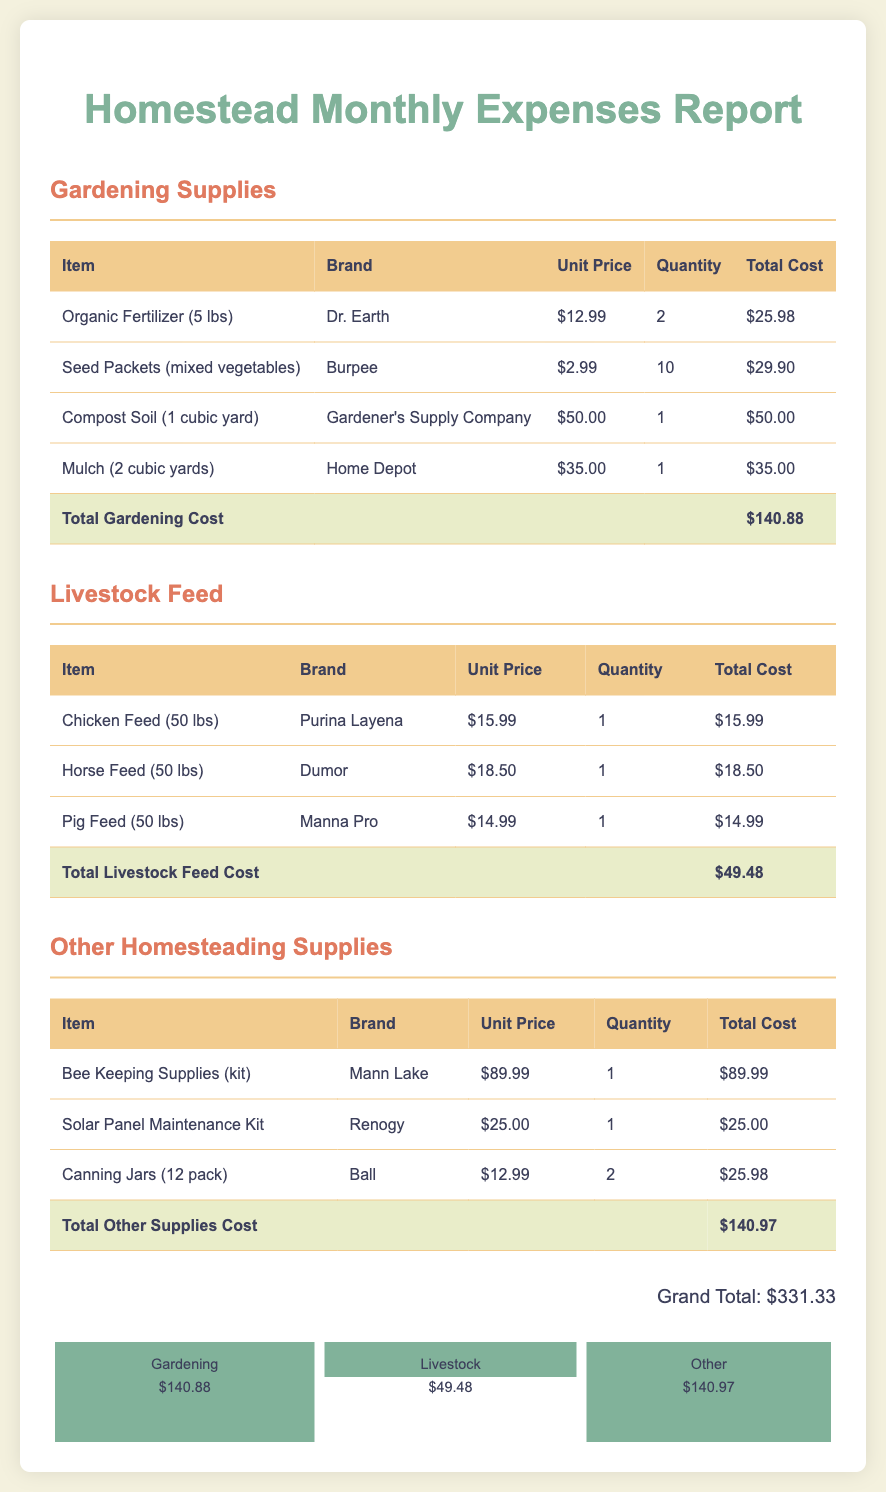What is the total cost of gardening supplies? The total cost of gardening supplies is provided in the report as a summary, which is $140.88.
Answer: $140.88 What brand is the chicken feed? The brand of the chicken feed listed in the document is Purina Layena.
Answer: Purina Layena How much did the solar panel maintenance kit cost? The price of the solar panel maintenance kit is indicated in the report, which is $25.00.
Answer: $25.00 What is the total cost of livestock feed? The total cost of livestock feed is summarized in the report as $49.48, combining all individual feed items.
Answer: $49.48 What is the grand total of all expenses? The grand total is provided as the sum of all expenses from the three sections, which is $331.33.
Answer: $331.33 How many chicken feed bags were purchased? The quantity of chicken feed bags bought is specified as 1 in the report.
Answer: 1 What was the unit price of organic fertilizer? The unit price for organic fertilizer stated in the document is $12.99.
Answer: $12.99 Which item had the highest cost in the other homesteading supplies? The item with the highest cost in the other supplies is the Bee Keeping Supplies (kit) at $89.99.
Answer: Bee Keeping Supplies (kit) How many seed packets were purchased? The report indicates that 10 seed packets were purchased.
Answer: 10 